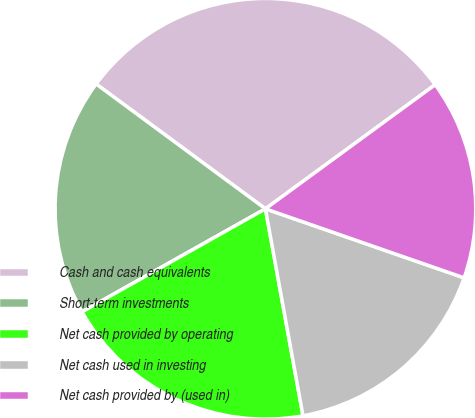Convert chart. <chart><loc_0><loc_0><loc_500><loc_500><pie_chart><fcel>Cash and cash equivalents<fcel>Short-term investments<fcel>Net cash provided by operating<fcel>Net cash used in investing<fcel>Net cash provided by (used in)<nl><fcel>29.84%<fcel>18.26%<fcel>19.71%<fcel>16.82%<fcel>15.37%<nl></chart> 